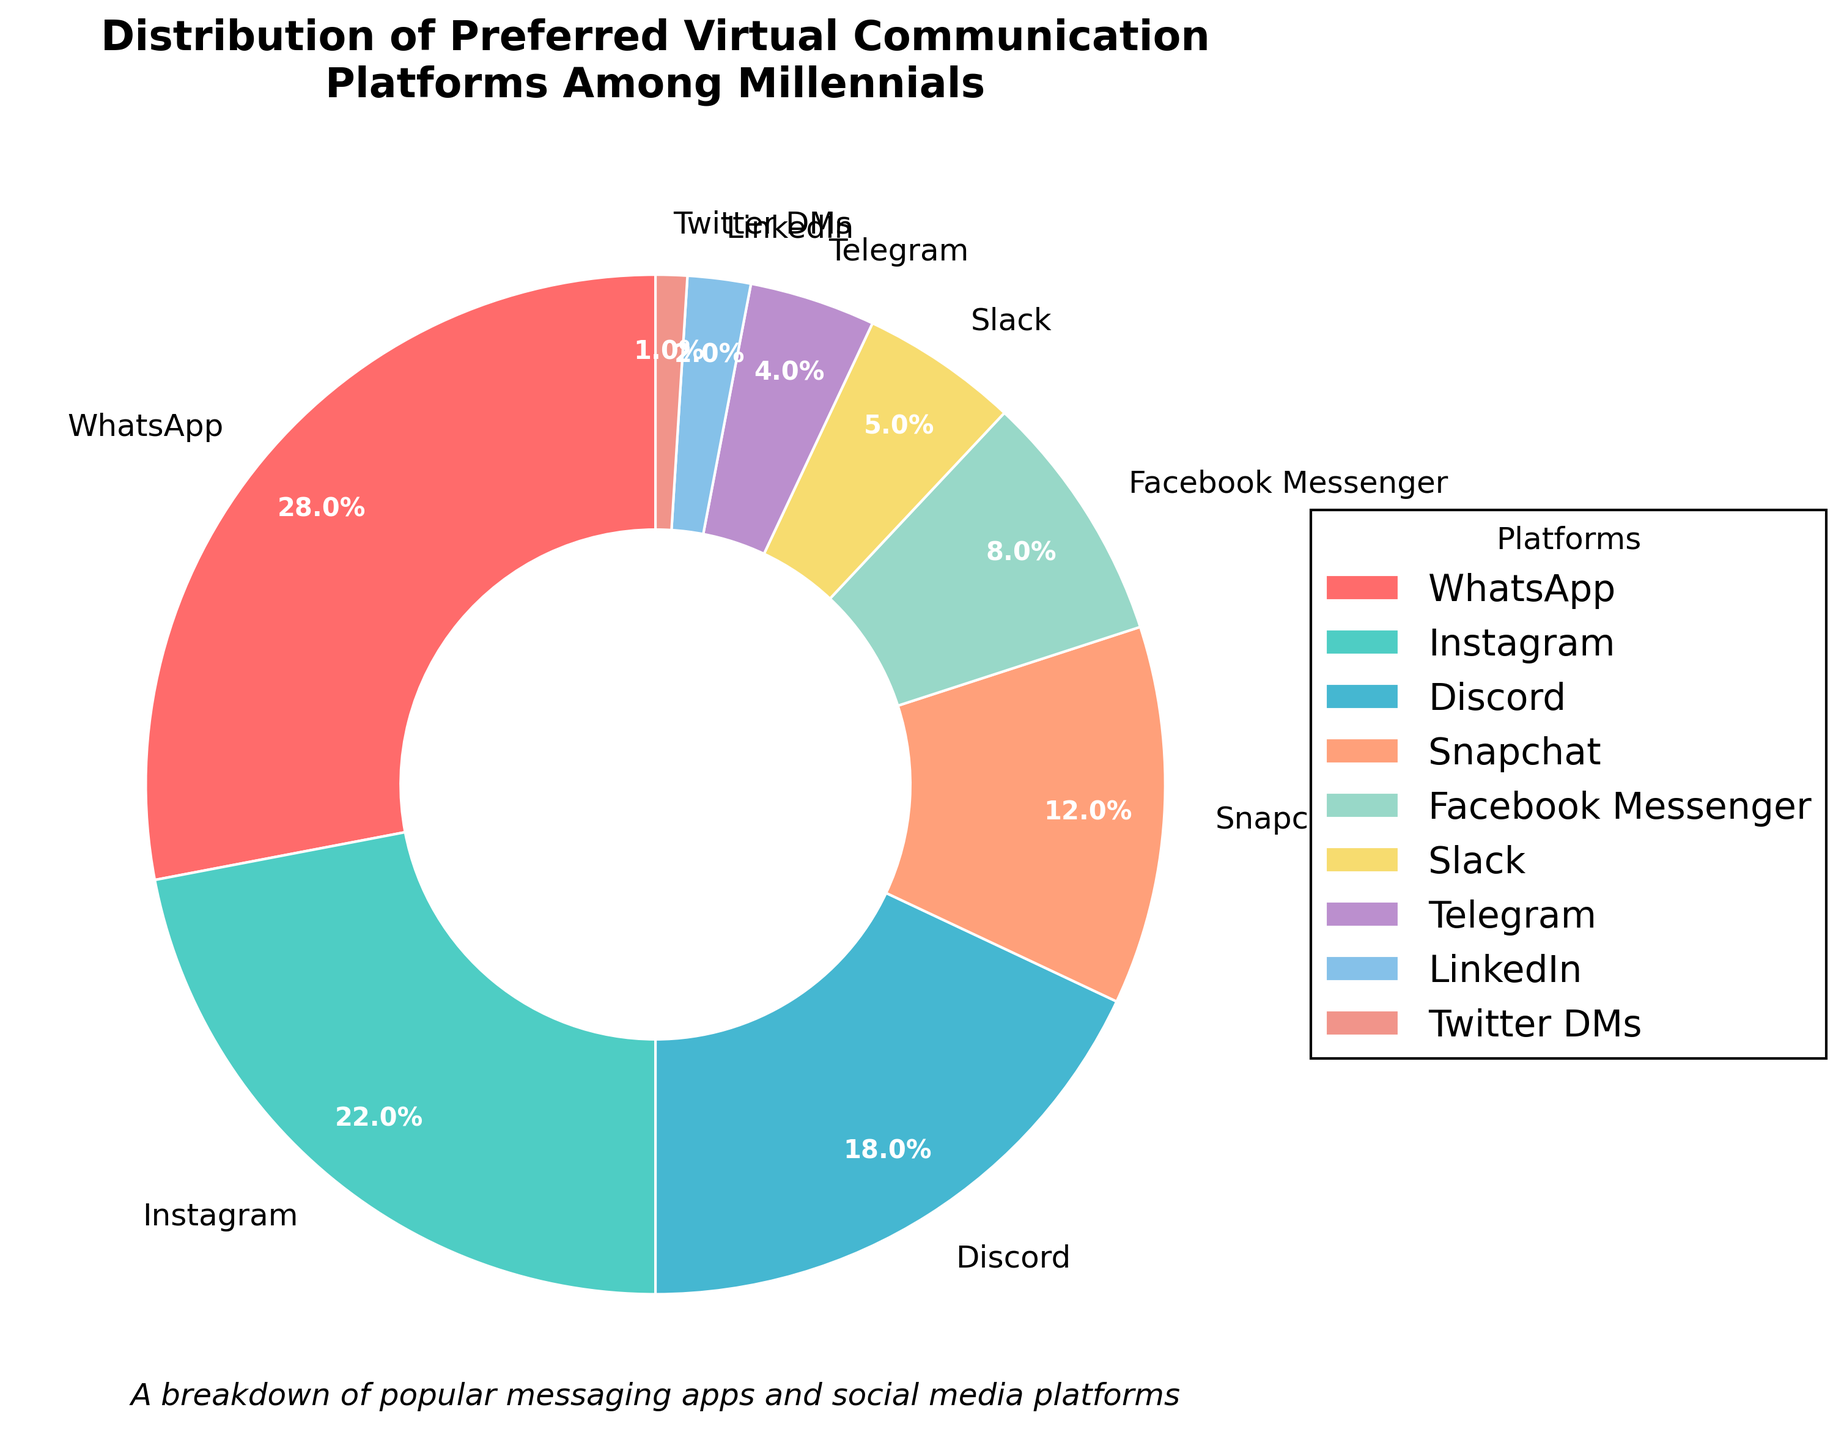What's the percentage of millennials preferring Instagram and Discord combined? To find the combined percentage, add the percentages for Instagram (22%) and Discord (18%). So, 22 + 18 equals 40.
Answer: 40% What platform do millennials prefer the least, and what is its percentage? The least preferred platform is the one with the smallest percentage. According to the chart, Twitter DMs has the smallest percentage of 1%.
Answer: Twitter DMs, 1% Which platform has a higher preference among millennials, Snapchat or Facebook Messenger? Compare the percentages for Snapchat (12%) and Facebook Messenger (8%). Since 12% is greater than 8%, Snapchat has a higher preference.
Answer: Snapchat How does the percentage of Telegram compare to that of Slack? Compare the percentages for Telegram (4%) and Slack (5%). Since 4% is less than 5%, Telegram has a lower percentage than Slack.
Answer: Telegram has a lower percentage What is the total percentage of millennials preferring Slack, Telegram, and LinkedIn? Add the percentages for Slack (5%), Telegram (4%), and LinkedIn (2%). So, 5 + 4 + 2 equals 11.
Answer: 11% How many platforms have a preference percentage greater than 10%? Identify platforms with percentages greater than 10%: WhatsApp (28%), Instagram (22%), Discord (18%), and Snapchat (12%). There are 4 such platforms.
Answer: 4 What is the difference in preference percentage between WhatsApp and Facebook Messenger? Subtract the percentage of Facebook Messenger (8%) from that of WhatsApp (28%). So, 28 - 8 equals 20.
Answer: 20% Which platform is shown in red and what is its percentage? The platform shown in red is identified visually. According to the color scheme, it is WhatsApp with a percentage of 28%.
Answer: WhatsApp, 28% What percentage of millennials prefer platforms other than WhatsApp, Instagram, and Discord? Subtract the combined percentage of WhatsApp (28%), Instagram (22%), and Discord (18%) from 100%. So, 100 - (28 + 22 + 18) equals 32.
Answer: 32% Is the percentage of millennials preferring Snapchat more than double the percentage of those preferring LinkedIn? Compare twice the LinkedIn percentage (2 * 2 = 4%) to Snapchat's percentage (12%). Since 12% is greater than 4%, the preference for Snapchat is indeed more than double.
Answer: Yes 